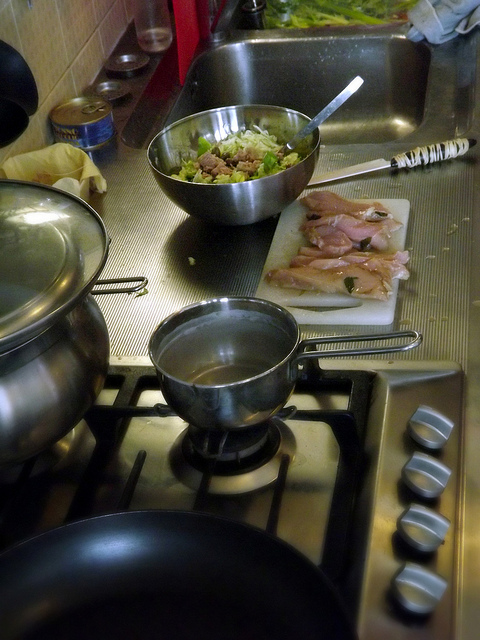<image>What is the slotted object? I don't know what the slotted object is. What is the slotted object? I don't know what the slotted object is. It can be a spoon, a knife, or something else. 